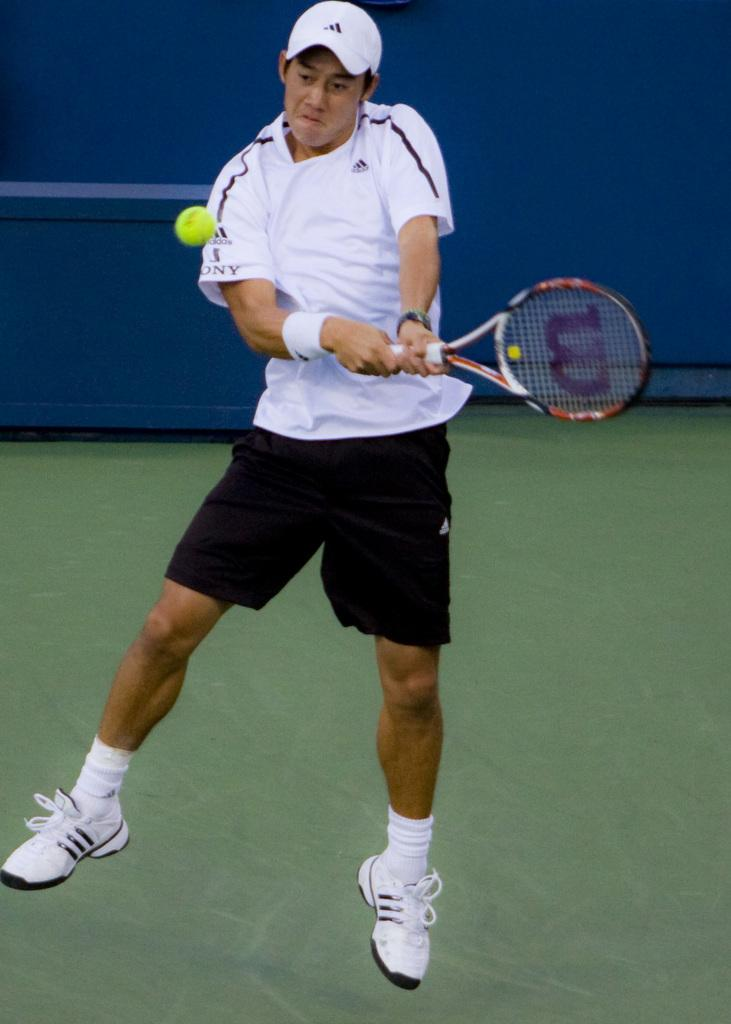What is the person in the image doing? The person is in the air, which suggests they are likely playing a sport or engaging in an activity that involves jumping or flying. What object is the person holding in the image? The person is holding a racket in the image. What is in front of the person in the image? There is a ball in front of the person in the image. What is behind the person in the image? There is a wall behind the person in the image. What type of letter is the person holding in the image? There is no letter present in the image; the person is holding a racket. 